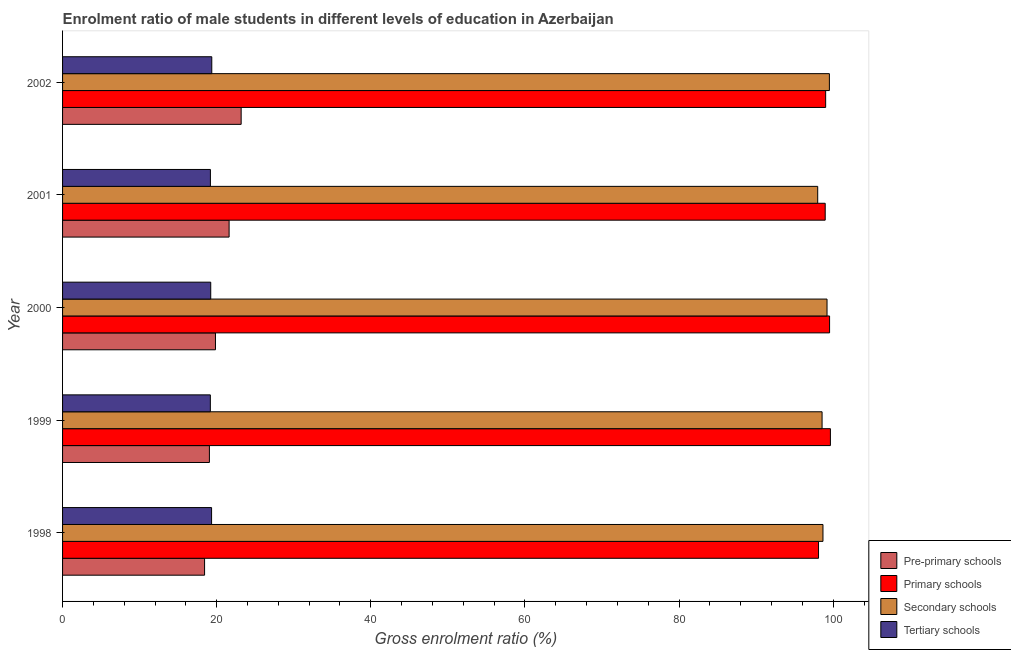How many different coloured bars are there?
Provide a succinct answer. 4. How many bars are there on the 1st tick from the top?
Offer a very short reply. 4. What is the gross enrolment ratio(female) in primary schools in 2001?
Your answer should be compact. 98.96. Across all years, what is the maximum gross enrolment ratio(female) in tertiary schools?
Keep it short and to the point. 19.36. Across all years, what is the minimum gross enrolment ratio(female) in pre-primary schools?
Give a very brief answer. 18.43. What is the total gross enrolment ratio(female) in primary schools in the graph?
Ensure brevity in your answer.  495.26. What is the difference between the gross enrolment ratio(female) in pre-primary schools in 2000 and that in 2001?
Offer a terse response. -1.77. What is the difference between the gross enrolment ratio(female) in primary schools in 2000 and the gross enrolment ratio(female) in tertiary schools in 2001?
Ensure brevity in your answer.  80.35. What is the average gross enrolment ratio(female) in pre-primary schools per year?
Ensure brevity in your answer.  20.42. In the year 2001, what is the difference between the gross enrolment ratio(female) in primary schools and gross enrolment ratio(female) in tertiary schools?
Your answer should be very brief. 79.78. In how many years, is the gross enrolment ratio(female) in pre-primary schools greater than 100 %?
Offer a terse response. 0. Is the gross enrolment ratio(female) in secondary schools in 2001 less than that in 2002?
Ensure brevity in your answer.  Yes. Is the difference between the gross enrolment ratio(female) in secondary schools in 1998 and 1999 greater than the difference between the gross enrolment ratio(female) in tertiary schools in 1998 and 1999?
Offer a very short reply. No. What is the difference between the highest and the second highest gross enrolment ratio(female) in secondary schools?
Offer a very short reply. 0.31. What is the difference between the highest and the lowest gross enrolment ratio(female) in tertiary schools?
Offer a terse response. 0.19. In how many years, is the gross enrolment ratio(female) in tertiary schools greater than the average gross enrolment ratio(female) in tertiary schools taken over all years?
Your answer should be very brief. 2. Is the sum of the gross enrolment ratio(female) in primary schools in 1999 and 2002 greater than the maximum gross enrolment ratio(female) in secondary schools across all years?
Offer a very short reply. Yes. Is it the case that in every year, the sum of the gross enrolment ratio(female) in tertiary schools and gross enrolment ratio(female) in pre-primary schools is greater than the sum of gross enrolment ratio(female) in secondary schools and gross enrolment ratio(female) in primary schools?
Your answer should be compact. No. What does the 4th bar from the top in 1999 represents?
Provide a short and direct response. Pre-primary schools. What does the 1st bar from the bottom in 1998 represents?
Ensure brevity in your answer.  Pre-primary schools. Is it the case that in every year, the sum of the gross enrolment ratio(female) in pre-primary schools and gross enrolment ratio(female) in primary schools is greater than the gross enrolment ratio(female) in secondary schools?
Provide a succinct answer. Yes. Are all the bars in the graph horizontal?
Make the answer very short. Yes. How many years are there in the graph?
Give a very brief answer. 5. How many legend labels are there?
Offer a very short reply. 4. What is the title of the graph?
Your answer should be very brief. Enrolment ratio of male students in different levels of education in Azerbaijan. Does "UNRWA" appear as one of the legend labels in the graph?
Give a very brief answer. No. What is the label or title of the Y-axis?
Provide a short and direct response. Year. What is the Gross enrolment ratio (%) of Pre-primary schools in 1998?
Your response must be concise. 18.43. What is the Gross enrolment ratio (%) in Primary schools in 1998?
Provide a short and direct response. 98.1. What is the Gross enrolment ratio (%) in Secondary schools in 1998?
Your answer should be very brief. 98.67. What is the Gross enrolment ratio (%) in Tertiary schools in 1998?
Your answer should be very brief. 19.34. What is the Gross enrolment ratio (%) in Pre-primary schools in 1999?
Provide a short and direct response. 19.05. What is the Gross enrolment ratio (%) of Primary schools in 1999?
Provide a short and direct response. 99.64. What is the Gross enrolment ratio (%) in Secondary schools in 1999?
Ensure brevity in your answer.  98.56. What is the Gross enrolment ratio (%) of Tertiary schools in 1999?
Give a very brief answer. 19.18. What is the Gross enrolment ratio (%) of Pre-primary schools in 2000?
Your response must be concise. 19.84. What is the Gross enrolment ratio (%) of Primary schools in 2000?
Provide a succinct answer. 99.53. What is the Gross enrolment ratio (%) in Secondary schools in 2000?
Provide a succinct answer. 99.2. What is the Gross enrolment ratio (%) in Tertiary schools in 2000?
Provide a short and direct response. 19.23. What is the Gross enrolment ratio (%) of Pre-primary schools in 2001?
Your response must be concise. 21.61. What is the Gross enrolment ratio (%) of Primary schools in 2001?
Offer a very short reply. 98.96. What is the Gross enrolment ratio (%) in Secondary schools in 2001?
Offer a very short reply. 97.99. What is the Gross enrolment ratio (%) in Tertiary schools in 2001?
Ensure brevity in your answer.  19.18. What is the Gross enrolment ratio (%) of Pre-primary schools in 2002?
Give a very brief answer. 23.17. What is the Gross enrolment ratio (%) in Primary schools in 2002?
Offer a very short reply. 99.02. What is the Gross enrolment ratio (%) of Secondary schools in 2002?
Ensure brevity in your answer.  99.51. What is the Gross enrolment ratio (%) in Tertiary schools in 2002?
Your response must be concise. 19.36. Across all years, what is the maximum Gross enrolment ratio (%) in Pre-primary schools?
Your response must be concise. 23.17. Across all years, what is the maximum Gross enrolment ratio (%) of Primary schools?
Make the answer very short. 99.64. Across all years, what is the maximum Gross enrolment ratio (%) of Secondary schools?
Provide a short and direct response. 99.51. Across all years, what is the maximum Gross enrolment ratio (%) of Tertiary schools?
Provide a succinct answer. 19.36. Across all years, what is the minimum Gross enrolment ratio (%) in Pre-primary schools?
Ensure brevity in your answer.  18.43. Across all years, what is the minimum Gross enrolment ratio (%) of Primary schools?
Provide a succinct answer. 98.1. Across all years, what is the minimum Gross enrolment ratio (%) in Secondary schools?
Your answer should be very brief. 97.99. Across all years, what is the minimum Gross enrolment ratio (%) of Tertiary schools?
Make the answer very short. 19.18. What is the total Gross enrolment ratio (%) in Pre-primary schools in the graph?
Your answer should be very brief. 102.11. What is the total Gross enrolment ratio (%) of Primary schools in the graph?
Keep it short and to the point. 495.26. What is the total Gross enrolment ratio (%) of Secondary schools in the graph?
Ensure brevity in your answer.  493.93. What is the total Gross enrolment ratio (%) in Tertiary schools in the graph?
Your answer should be very brief. 96.29. What is the difference between the Gross enrolment ratio (%) in Pre-primary schools in 1998 and that in 1999?
Keep it short and to the point. -0.62. What is the difference between the Gross enrolment ratio (%) in Primary schools in 1998 and that in 1999?
Your answer should be very brief. -1.54. What is the difference between the Gross enrolment ratio (%) of Secondary schools in 1998 and that in 1999?
Offer a terse response. 0.12. What is the difference between the Gross enrolment ratio (%) in Tertiary schools in 1998 and that in 1999?
Give a very brief answer. 0.16. What is the difference between the Gross enrolment ratio (%) of Pre-primary schools in 1998 and that in 2000?
Give a very brief answer. -1.41. What is the difference between the Gross enrolment ratio (%) in Primary schools in 1998 and that in 2000?
Offer a very short reply. -1.43. What is the difference between the Gross enrolment ratio (%) of Secondary schools in 1998 and that in 2000?
Your response must be concise. -0.53. What is the difference between the Gross enrolment ratio (%) of Tertiary schools in 1998 and that in 2000?
Provide a succinct answer. 0.11. What is the difference between the Gross enrolment ratio (%) of Pre-primary schools in 1998 and that in 2001?
Offer a very short reply. -3.18. What is the difference between the Gross enrolment ratio (%) of Primary schools in 1998 and that in 2001?
Make the answer very short. -0.87. What is the difference between the Gross enrolment ratio (%) of Secondary schools in 1998 and that in 2001?
Keep it short and to the point. 0.68. What is the difference between the Gross enrolment ratio (%) in Tertiary schools in 1998 and that in 2001?
Offer a very short reply. 0.15. What is the difference between the Gross enrolment ratio (%) in Pre-primary schools in 1998 and that in 2002?
Your response must be concise. -4.75. What is the difference between the Gross enrolment ratio (%) in Primary schools in 1998 and that in 2002?
Ensure brevity in your answer.  -0.92. What is the difference between the Gross enrolment ratio (%) of Secondary schools in 1998 and that in 2002?
Your answer should be compact. -0.83. What is the difference between the Gross enrolment ratio (%) in Tertiary schools in 1998 and that in 2002?
Ensure brevity in your answer.  -0.03. What is the difference between the Gross enrolment ratio (%) in Pre-primary schools in 1999 and that in 2000?
Ensure brevity in your answer.  -0.79. What is the difference between the Gross enrolment ratio (%) in Primary schools in 1999 and that in 2000?
Give a very brief answer. 0.11. What is the difference between the Gross enrolment ratio (%) in Secondary schools in 1999 and that in 2000?
Offer a very short reply. -0.64. What is the difference between the Gross enrolment ratio (%) in Tertiary schools in 1999 and that in 2000?
Make the answer very short. -0.05. What is the difference between the Gross enrolment ratio (%) of Pre-primary schools in 1999 and that in 2001?
Keep it short and to the point. -2.56. What is the difference between the Gross enrolment ratio (%) in Primary schools in 1999 and that in 2001?
Offer a terse response. 0.68. What is the difference between the Gross enrolment ratio (%) of Secondary schools in 1999 and that in 2001?
Offer a very short reply. 0.57. What is the difference between the Gross enrolment ratio (%) of Tertiary schools in 1999 and that in 2001?
Ensure brevity in your answer.  -0.01. What is the difference between the Gross enrolment ratio (%) in Pre-primary schools in 1999 and that in 2002?
Your response must be concise. -4.12. What is the difference between the Gross enrolment ratio (%) of Primary schools in 1999 and that in 2002?
Provide a short and direct response. 0.62. What is the difference between the Gross enrolment ratio (%) of Secondary schools in 1999 and that in 2002?
Provide a succinct answer. -0.95. What is the difference between the Gross enrolment ratio (%) in Tertiary schools in 1999 and that in 2002?
Offer a terse response. -0.19. What is the difference between the Gross enrolment ratio (%) in Pre-primary schools in 2000 and that in 2001?
Your response must be concise. -1.77. What is the difference between the Gross enrolment ratio (%) of Primary schools in 2000 and that in 2001?
Give a very brief answer. 0.57. What is the difference between the Gross enrolment ratio (%) in Secondary schools in 2000 and that in 2001?
Offer a very short reply. 1.21. What is the difference between the Gross enrolment ratio (%) in Tertiary schools in 2000 and that in 2001?
Provide a succinct answer. 0.04. What is the difference between the Gross enrolment ratio (%) of Pre-primary schools in 2000 and that in 2002?
Make the answer very short. -3.33. What is the difference between the Gross enrolment ratio (%) of Primary schools in 2000 and that in 2002?
Make the answer very short. 0.51. What is the difference between the Gross enrolment ratio (%) of Secondary schools in 2000 and that in 2002?
Provide a succinct answer. -0.31. What is the difference between the Gross enrolment ratio (%) of Tertiary schools in 2000 and that in 2002?
Ensure brevity in your answer.  -0.13. What is the difference between the Gross enrolment ratio (%) of Pre-primary schools in 2001 and that in 2002?
Make the answer very short. -1.56. What is the difference between the Gross enrolment ratio (%) of Primary schools in 2001 and that in 2002?
Give a very brief answer. -0.06. What is the difference between the Gross enrolment ratio (%) of Secondary schools in 2001 and that in 2002?
Give a very brief answer. -1.52. What is the difference between the Gross enrolment ratio (%) of Tertiary schools in 2001 and that in 2002?
Your answer should be very brief. -0.18. What is the difference between the Gross enrolment ratio (%) in Pre-primary schools in 1998 and the Gross enrolment ratio (%) in Primary schools in 1999?
Provide a short and direct response. -81.21. What is the difference between the Gross enrolment ratio (%) of Pre-primary schools in 1998 and the Gross enrolment ratio (%) of Secondary schools in 1999?
Your answer should be compact. -80.13. What is the difference between the Gross enrolment ratio (%) in Pre-primary schools in 1998 and the Gross enrolment ratio (%) in Tertiary schools in 1999?
Give a very brief answer. -0.75. What is the difference between the Gross enrolment ratio (%) in Primary schools in 1998 and the Gross enrolment ratio (%) in Secondary schools in 1999?
Keep it short and to the point. -0.46. What is the difference between the Gross enrolment ratio (%) of Primary schools in 1998 and the Gross enrolment ratio (%) of Tertiary schools in 1999?
Provide a short and direct response. 78.92. What is the difference between the Gross enrolment ratio (%) in Secondary schools in 1998 and the Gross enrolment ratio (%) in Tertiary schools in 1999?
Provide a succinct answer. 79.5. What is the difference between the Gross enrolment ratio (%) in Pre-primary schools in 1998 and the Gross enrolment ratio (%) in Primary schools in 2000?
Provide a short and direct response. -81.1. What is the difference between the Gross enrolment ratio (%) in Pre-primary schools in 1998 and the Gross enrolment ratio (%) in Secondary schools in 2000?
Offer a very short reply. -80.77. What is the difference between the Gross enrolment ratio (%) in Pre-primary schools in 1998 and the Gross enrolment ratio (%) in Tertiary schools in 2000?
Your answer should be very brief. -0.8. What is the difference between the Gross enrolment ratio (%) of Primary schools in 1998 and the Gross enrolment ratio (%) of Secondary schools in 2000?
Make the answer very short. -1.1. What is the difference between the Gross enrolment ratio (%) of Primary schools in 1998 and the Gross enrolment ratio (%) of Tertiary schools in 2000?
Your response must be concise. 78.87. What is the difference between the Gross enrolment ratio (%) of Secondary schools in 1998 and the Gross enrolment ratio (%) of Tertiary schools in 2000?
Your answer should be very brief. 79.45. What is the difference between the Gross enrolment ratio (%) in Pre-primary schools in 1998 and the Gross enrolment ratio (%) in Primary schools in 2001?
Your answer should be very brief. -80.54. What is the difference between the Gross enrolment ratio (%) of Pre-primary schools in 1998 and the Gross enrolment ratio (%) of Secondary schools in 2001?
Provide a succinct answer. -79.56. What is the difference between the Gross enrolment ratio (%) of Pre-primary schools in 1998 and the Gross enrolment ratio (%) of Tertiary schools in 2001?
Provide a short and direct response. -0.76. What is the difference between the Gross enrolment ratio (%) in Primary schools in 1998 and the Gross enrolment ratio (%) in Secondary schools in 2001?
Make the answer very short. 0.11. What is the difference between the Gross enrolment ratio (%) of Primary schools in 1998 and the Gross enrolment ratio (%) of Tertiary schools in 2001?
Ensure brevity in your answer.  78.91. What is the difference between the Gross enrolment ratio (%) of Secondary schools in 1998 and the Gross enrolment ratio (%) of Tertiary schools in 2001?
Offer a terse response. 79.49. What is the difference between the Gross enrolment ratio (%) in Pre-primary schools in 1998 and the Gross enrolment ratio (%) in Primary schools in 2002?
Provide a short and direct response. -80.59. What is the difference between the Gross enrolment ratio (%) of Pre-primary schools in 1998 and the Gross enrolment ratio (%) of Secondary schools in 2002?
Ensure brevity in your answer.  -81.08. What is the difference between the Gross enrolment ratio (%) of Pre-primary schools in 1998 and the Gross enrolment ratio (%) of Tertiary schools in 2002?
Provide a succinct answer. -0.93. What is the difference between the Gross enrolment ratio (%) in Primary schools in 1998 and the Gross enrolment ratio (%) in Secondary schools in 2002?
Your answer should be very brief. -1.41. What is the difference between the Gross enrolment ratio (%) of Primary schools in 1998 and the Gross enrolment ratio (%) of Tertiary schools in 2002?
Give a very brief answer. 78.74. What is the difference between the Gross enrolment ratio (%) in Secondary schools in 1998 and the Gross enrolment ratio (%) in Tertiary schools in 2002?
Your answer should be compact. 79.31. What is the difference between the Gross enrolment ratio (%) of Pre-primary schools in 1999 and the Gross enrolment ratio (%) of Primary schools in 2000?
Your answer should be compact. -80.48. What is the difference between the Gross enrolment ratio (%) in Pre-primary schools in 1999 and the Gross enrolment ratio (%) in Secondary schools in 2000?
Offer a terse response. -80.15. What is the difference between the Gross enrolment ratio (%) of Pre-primary schools in 1999 and the Gross enrolment ratio (%) of Tertiary schools in 2000?
Your response must be concise. -0.17. What is the difference between the Gross enrolment ratio (%) of Primary schools in 1999 and the Gross enrolment ratio (%) of Secondary schools in 2000?
Provide a short and direct response. 0.44. What is the difference between the Gross enrolment ratio (%) in Primary schools in 1999 and the Gross enrolment ratio (%) in Tertiary schools in 2000?
Provide a short and direct response. 80.41. What is the difference between the Gross enrolment ratio (%) in Secondary schools in 1999 and the Gross enrolment ratio (%) in Tertiary schools in 2000?
Your answer should be very brief. 79.33. What is the difference between the Gross enrolment ratio (%) of Pre-primary schools in 1999 and the Gross enrolment ratio (%) of Primary schools in 2001?
Ensure brevity in your answer.  -79.91. What is the difference between the Gross enrolment ratio (%) of Pre-primary schools in 1999 and the Gross enrolment ratio (%) of Secondary schools in 2001?
Your answer should be compact. -78.94. What is the difference between the Gross enrolment ratio (%) of Pre-primary schools in 1999 and the Gross enrolment ratio (%) of Tertiary schools in 2001?
Your response must be concise. -0.13. What is the difference between the Gross enrolment ratio (%) in Primary schools in 1999 and the Gross enrolment ratio (%) in Secondary schools in 2001?
Provide a short and direct response. 1.65. What is the difference between the Gross enrolment ratio (%) in Primary schools in 1999 and the Gross enrolment ratio (%) in Tertiary schools in 2001?
Your answer should be compact. 80.46. What is the difference between the Gross enrolment ratio (%) in Secondary schools in 1999 and the Gross enrolment ratio (%) in Tertiary schools in 2001?
Provide a succinct answer. 79.37. What is the difference between the Gross enrolment ratio (%) in Pre-primary schools in 1999 and the Gross enrolment ratio (%) in Primary schools in 2002?
Keep it short and to the point. -79.97. What is the difference between the Gross enrolment ratio (%) of Pre-primary schools in 1999 and the Gross enrolment ratio (%) of Secondary schools in 2002?
Keep it short and to the point. -80.45. What is the difference between the Gross enrolment ratio (%) of Pre-primary schools in 1999 and the Gross enrolment ratio (%) of Tertiary schools in 2002?
Your answer should be very brief. -0.31. What is the difference between the Gross enrolment ratio (%) in Primary schools in 1999 and the Gross enrolment ratio (%) in Secondary schools in 2002?
Give a very brief answer. 0.13. What is the difference between the Gross enrolment ratio (%) of Primary schools in 1999 and the Gross enrolment ratio (%) of Tertiary schools in 2002?
Your answer should be very brief. 80.28. What is the difference between the Gross enrolment ratio (%) of Secondary schools in 1999 and the Gross enrolment ratio (%) of Tertiary schools in 2002?
Your response must be concise. 79.2. What is the difference between the Gross enrolment ratio (%) of Pre-primary schools in 2000 and the Gross enrolment ratio (%) of Primary schools in 2001?
Your response must be concise. -79.12. What is the difference between the Gross enrolment ratio (%) in Pre-primary schools in 2000 and the Gross enrolment ratio (%) in Secondary schools in 2001?
Provide a succinct answer. -78.15. What is the difference between the Gross enrolment ratio (%) of Pre-primary schools in 2000 and the Gross enrolment ratio (%) of Tertiary schools in 2001?
Offer a terse response. 0.66. What is the difference between the Gross enrolment ratio (%) in Primary schools in 2000 and the Gross enrolment ratio (%) in Secondary schools in 2001?
Keep it short and to the point. 1.54. What is the difference between the Gross enrolment ratio (%) of Primary schools in 2000 and the Gross enrolment ratio (%) of Tertiary schools in 2001?
Keep it short and to the point. 80.35. What is the difference between the Gross enrolment ratio (%) of Secondary schools in 2000 and the Gross enrolment ratio (%) of Tertiary schools in 2001?
Make the answer very short. 80.02. What is the difference between the Gross enrolment ratio (%) in Pre-primary schools in 2000 and the Gross enrolment ratio (%) in Primary schools in 2002?
Provide a short and direct response. -79.18. What is the difference between the Gross enrolment ratio (%) in Pre-primary schools in 2000 and the Gross enrolment ratio (%) in Secondary schools in 2002?
Keep it short and to the point. -79.67. What is the difference between the Gross enrolment ratio (%) of Pre-primary schools in 2000 and the Gross enrolment ratio (%) of Tertiary schools in 2002?
Provide a short and direct response. 0.48. What is the difference between the Gross enrolment ratio (%) in Primary schools in 2000 and the Gross enrolment ratio (%) in Secondary schools in 2002?
Provide a succinct answer. 0.02. What is the difference between the Gross enrolment ratio (%) in Primary schools in 2000 and the Gross enrolment ratio (%) in Tertiary schools in 2002?
Make the answer very short. 80.17. What is the difference between the Gross enrolment ratio (%) of Secondary schools in 2000 and the Gross enrolment ratio (%) of Tertiary schools in 2002?
Provide a short and direct response. 79.84. What is the difference between the Gross enrolment ratio (%) in Pre-primary schools in 2001 and the Gross enrolment ratio (%) in Primary schools in 2002?
Provide a succinct answer. -77.41. What is the difference between the Gross enrolment ratio (%) of Pre-primary schools in 2001 and the Gross enrolment ratio (%) of Secondary schools in 2002?
Make the answer very short. -77.9. What is the difference between the Gross enrolment ratio (%) of Pre-primary schools in 2001 and the Gross enrolment ratio (%) of Tertiary schools in 2002?
Keep it short and to the point. 2.25. What is the difference between the Gross enrolment ratio (%) of Primary schools in 2001 and the Gross enrolment ratio (%) of Secondary schools in 2002?
Keep it short and to the point. -0.54. What is the difference between the Gross enrolment ratio (%) in Primary schools in 2001 and the Gross enrolment ratio (%) in Tertiary schools in 2002?
Ensure brevity in your answer.  79.6. What is the difference between the Gross enrolment ratio (%) in Secondary schools in 2001 and the Gross enrolment ratio (%) in Tertiary schools in 2002?
Provide a short and direct response. 78.63. What is the average Gross enrolment ratio (%) of Pre-primary schools per year?
Keep it short and to the point. 20.42. What is the average Gross enrolment ratio (%) in Primary schools per year?
Give a very brief answer. 99.05. What is the average Gross enrolment ratio (%) in Secondary schools per year?
Offer a terse response. 98.79. What is the average Gross enrolment ratio (%) in Tertiary schools per year?
Your response must be concise. 19.26. In the year 1998, what is the difference between the Gross enrolment ratio (%) of Pre-primary schools and Gross enrolment ratio (%) of Primary schools?
Your answer should be very brief. -79.67. In the year 1998, what is the difference between the Gross enrolment ratio (%) of Pre-primary schools and Gross enrolment ratio (%) of Secondary schools?
Ensure brevity in your answer.  -80.24. In the year 1998, what is the difference between the Gross enrolment ratio (%) of Pre-primary schools and Gross enrolment ratio (%) of Tertiary schools?
Your answer should be very brief. -0.91. In the year 1998, what is the difference between the Gross enrolment ratio (%) of Primary schools and Gross enrolment ratio (%) of Secondary schools?
Keep it short and to the point. -0.58. In the year 1998, what is the difference between the Gross enrolment ratio (%) of Primary schools and Gross enrolment ratio (%) of Tertiary schools?
Offer a terse response. 78.76. In the year 1998, what is the difference between the Gross enrolment ratio (%) of Secondary schools and Gross enrolment ratio (%) of Tertiary schools?
Your answer should be very brief. 79.34. In the year 1999, what is the difference between the Gross enrolment ratio (%) in Pre-primary schools and Gross enrolment ratio (%) in Primary schools?
Keep it short and to the point. -80.59. In the year 1999, what is the difference between the Gross enrolment ratio (%) in Pre-primary schools and Gross enrolment ratio (%) in Secondary schools?
Offer a terse response. -79.5. In the year 1999, what is the difference between the Gross enrolment ratio (%) in Pre-primary schools and Gross enrolment ratio (%) in Tertiary schools?
Your answer should be very brief. -0.12. In the year 1999, what is the difference between the Gross enrolment ratio (%) of Primary schools and Gross enrolment ratio (%) of Secondary schools?
Provide a succinct answer. 1.08. In the year 1999, what is the difference between the Gross enrolment ratio (%) of Primary schools and Gross enrolment ratio (%) of Tertiary schools?
Make the answer very short. 80.46. In the year 1999, what is the difference between the Gross enrolment ratio (%) in Secondary schools and Gross enrolment ratio (%) in Tertiary schools?
Offer a very short reply. 79.38. In the year 2000, what is the difference between the Gross enrolment ratio (%) in Pre-primary schools and Gross enrolment ratio (%) in Primary schools?
Provide a short and direct response. -79.69. In the year 2000, what is the difference between the Gross enrolment ratio (%) of Pre-primary schools and Gross enrolment ratio (%) of Secondary schools?
Offer a terse response. -79.36. In the year 2000, what is the difference between the Gross enrolment ratio (%) in Pre-primary schools and Gross enrolment ratio (%) in Tertiary schools?
Make the answer very short. 0.61. In the year 2000, what is the difference between the Gross enrolment ratio (%) in Primary schools and Gross enrolment ratio (%) in Secondary schools?
Your answer should be very brief. 0.33. In the year 2000, what is the difference between the Gross enrolment ratio (%) in Primary schools and Gross enrolment ratio (%) in Tertiary schools?
Provide a short and direct response. 80.3. In the year 2000, what is the difference between the Gross enrolment ratio (%) in Secondary schools and Gross enrolment ratio (%) in Tertiary schools?
Provide a short and direct response. 79.97. In the year 2001, what is the difference between the Gross enrolment ratio (%) of Pre-primary schools and Gross enrolment ratio (%) of Primary schools?
Give a very brief answer. -77.35. In the year 2001, what is the difference between the Gross enrolment ratio (%) of Pre-primary schools and Gross enrolment ratio (%) of Secondary schools?
Your answer should be compact. -76.38. In the year 2001, what is the difference between the Gross enrolment ratio (%) in Pre-primary schools and Gross enrolment ratio (%) in Tertiary schools?
Provide a short and direct response. 2.43. In the year 2001, what is the difference between the Gross enrolment ratio (%) in Primary schools and Gross enrolment ratio (%) in Secondary schools?
Your answer should be very brief. 0.98. In the year 2001, what is the difference between the Gross enrolment ratio (%) of Primary schools and Gross enrolment ratio (%) of Tertiary schools?
Your answer should be compact. 79.78. In the year 2001, what is the difference between the Gross enrolment ratio (%) in Secondary schools and Gross enrolment ratio (%) in Tertiary schools?
Offer a terse response. 78.81. In the year 2002, what is the difference between the Gross enrolment ratio (%) of Pre-primary schools and Gross enrolment ratio (%) of Primary schools?
Offer a very short reply. -75.85. In the year 2002, what is the difference between the Gross enrolment ratio (%) in Pre-primary schools and Gross enrolment ratio (%) in Secondary schools?
Your response must be concise. -76.33. In the year 2002, what is the difference between the Gross enrolment ratio (%) of Pre-primary schools and Gross enrolment ratio (%) of Tertiary schools?
Provide a succinct answer. 3.81. In the year 2002, what is the difference between the Gross enrolment ratio (%) of Primary schools and Gross enrolment ratio (%) of Secondary schools?
Keep it short and to the point. -0.49. In the year 2002, what is the difference between the Gross enrolment ratio (%) in Primary schools and Gross enrolment ratio (%) in Tertiary schools?
Give a very brief answer. 79.66. In the year 2002, what is the difference between the Gross enrolment ratio (%) of Secondary schools and Gross enrolment ratio (%) of Tertiary schools?
Ensure brevity in your answer.  80.15. What is the ratio of the Gross enrolment ratio (%) in Pre-primary schools in 1998 to that in 1999?
Provide a succinct answer. 0.97. What is the ratio of the Gross enrolment ratio (%) in Primary schools in 1998 to that in 1999?
Keep it short and to the point. 0.98. What is the ratio of the Gross enrolment ratio (%) of Tertiary schools in 1998 to that in 1999?
Provide a short and direct response. 1.01. What is the ratio of the Gross enrolment ratio (%) in Pre-primary schools in 1998 to that in 2000?
Provide a succinct answer. 0.93. What is the ratio of the Gross enrolment ratio (%) in Primary schools in 1998 to that in 2000?
Offer a very short reply. 0.99. What is the ratio of the Gross enrolment ratio (%) of Tertiary schools in 1998 to that in 2000?
Offer a terse response. 1.01. What is the ratio of the Gross enrolment ratio (%) in Pre-primary schools in 1998 to that in 2001?
Keep it short and to the point. 0.85. What is the ratio of the Gross enrolment ratio (%) of Secondary schools in 1998 to that in 2001?
Your answer should be compact. 1.01. What is the ratio of the Gross enrolment ratio (%) of Tertiary schools in 1998 to that in 2001?
Provide a succinct answer. 1.01. What is the ratio of the Gross enrolment ratio (%) of Pre-primary schools in 1998 to that in 2002?
Keep it short and to the point. 0.8. What is the ratio of the Gross enrolment ratio (%) in Secondary schools in 1998 to that in 2002?
Provide a short and direct response. 0.99. What is the ratio of the Gross enrolment ratio (%) in Tertiary schools in 1998 to that in 2002?
Offer a terse response. 1. What is the ratio of the Gross enrolment ratio (%) in Pre-primary schools in 1999 to that in 2000?
Offer a very short reply. 0.96. What is the ratio of the Gross enrolment ratio (%) in Tertiary schools in 1999 to that in 2000?
Ensure brevity in your answer.  1. What is the ratio of the Gross enrolment ratio (%) in Pre-primary schools in 1999 to that in 2001?
Your response must be concise. 0.88. What is the ratio of the Gross enrolment ratio (%) in Primary schools in 1999 to that in 2001?
Offer a very short reply. 1.01. What is the ratio of the Gross enrolment ratio (%) of Secondary schools in 1999 to that in 2001?
Provide a succinct answer. 1.01. What is the ratio of the Gross enrolment ratio (%) of Pre-primary schools in 1999 to that in 2002?
Provide a succinct answer. 0.82. What is the ratio of the Gross enrolment ratio (%) of Secondary schools in 1999 to that in 2002?
Offer a terse response. 0.99. What is the ratio of the Gross enrolment ratio (%) in Tertiary schools in 1999 to that in 2002?
Provide a short and direct response. 0.99. What is the ratio of the Gross enrolment ratio (%) in Pre-primary schools in 2000 to that in 2001?
Give a very brief answer. 0.92. What is the ratio of the Gross enrolment ratio (%) in Secondary schools in 2000 to that in 2001?
Your response must be concise. 1.01. What is the ratio of the Gross enrolment ratio (%) in Tertiary schools in 2000 to that in 2001?
Your answer should be compact. 1. What is the ratio of the Gross enrolment ratio (%) in Pre-primary schools in 2000 to that in 2002?
Offer a terse response. 0.86. What is the ratio of the Gross enrolment ratio (%) in Primary schools in 2000 to that in 2002?
Your answer should be very brief. 1.01. What is the ratio of the Gross enrolment ratio (%) of Tertiary schools in 2000 to that in 2002?
Ensure brevity in your answer.  0.99. What is the ratio of the Gross enrolment ratio (%) in Pre-primary schools in 2001 to that in 2002?
Your answer should be compact. 0.93. What is the ratio of the Gross enrolment ratio (%) of Primary schools in 2001 to that in 2002?
Make the answer very short. 1. What is the ratio of the Gross enrolment ratio (%) of Secondary schools in 2001 to that in 2002?
Ensure brevity in your answer.  0.98. What is the ratio of the Gross enrolment ratio (%) of Tertiary schools in 2001 to that in 2002?
Give a very brief answer. 0.99. What is the difference between the highest and the second highest Gross enrolment ratio (%) in Pre-primary schools?
Your answer should be compact. 1.56. What is the difference between the highest and the second highest Gross enrolment ratio (%) of Primary schools?
Your answer should be very brief. 0.11. What is the difference between the highest and the second highest Gross enrolment ratio (%) of Secondary schools?
Your answer should be compact. 0.31. What is the difference between the highest and the second highest Gross enrolment ratio (%) of Tertiary schools?
Give a very brief answer. 0.03. What is the difference between the highest and the lowest Gross enrolment ratio (%) of Pre-primary schools?
Give a very brief answer. 4.75. What is the difference between the highest and the lowest Gross enrolment ratio (%) in Primary schools?
Your response must be concise. 1.54. What is the difference between the highest and the lowest Gross enrolment ratio (%) in Secondary schools?
Your answer should be very brief. 1.52. What is the difference between the highest and the lowest Gross enrolment ratio (%) of Tertiary schools?
Provide a succinct answer. 0.19. 